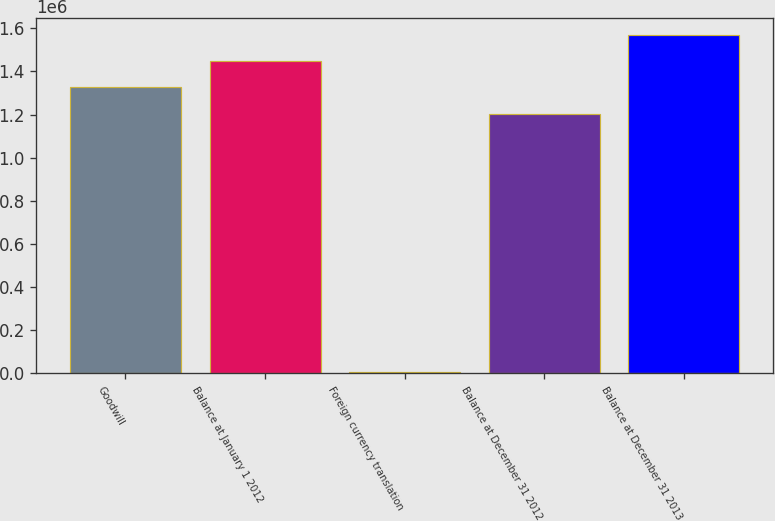Convert chart. <chart><loc_0><loc_0><loc_500><loc_500><bar_chart><fcel>Goodwill<fcel>Balance at January 1 2012<fcel>Foreign currency translation<fcel>Balance at December 31 2012<fcel>Balance at December 31 2013<nl><fcel>1.32561e+06<fcel>1.44693e+06<fcel>6711<fcel>1.2043e+06<fcel>1.56825e+06<nl></chart> 